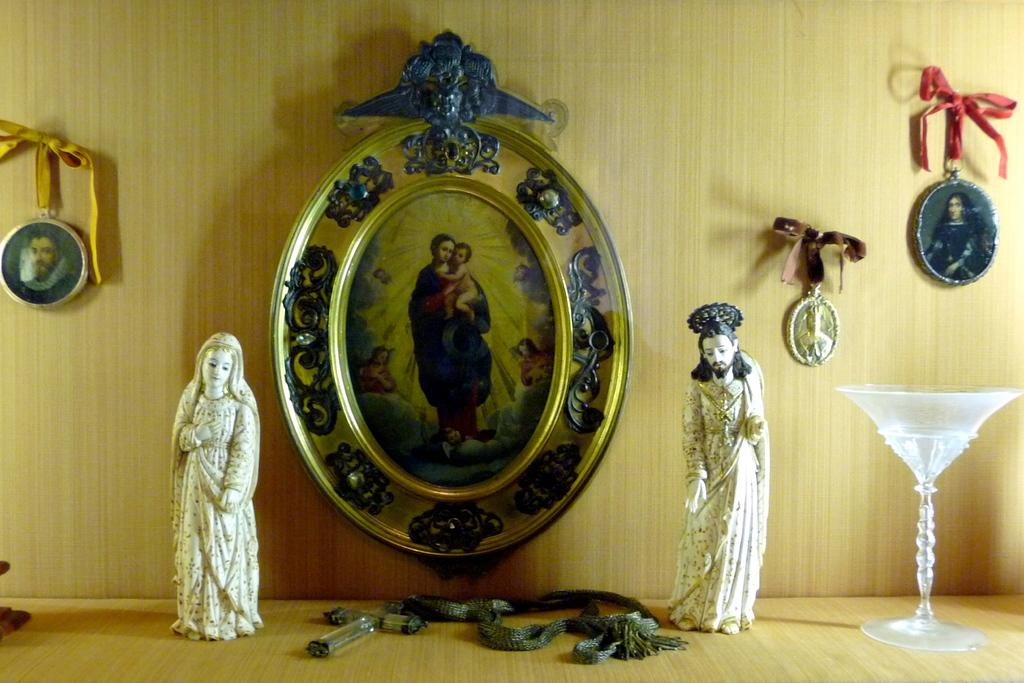What is the main object in the middle of the image? There is a photo frame in the middle of the image. What is located on either side of the photo frame? There are two statues on either side of the photo frame. Can you identify any other objects in the image? Yes, there is a glass on the right side of the image. How many robins can be seen kicking a soccer ball in the image? There are no robins or soccer balls present in the image. 